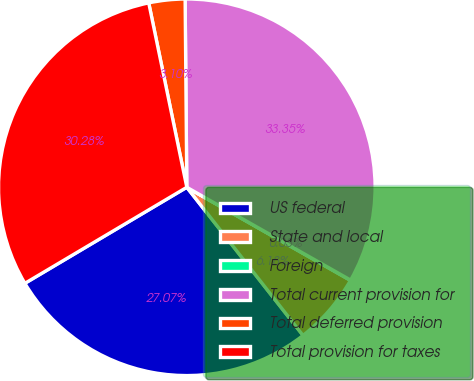Convert chart to OTSL. <chart><loc_0><loc_0><loc_500><loc_500><pie_chart><fcel>US federal<fcel>State and local<fcel>Foreign<fcel>Total current provision for<fcel>Total deferred provision<fcel>Total provision for taxes<nl><fcel>27.07%<fcel>6.18%<fcel>0.03%<fcel>33.35%<fcel>3.1%<fcel>30.28%<nl></chart> 